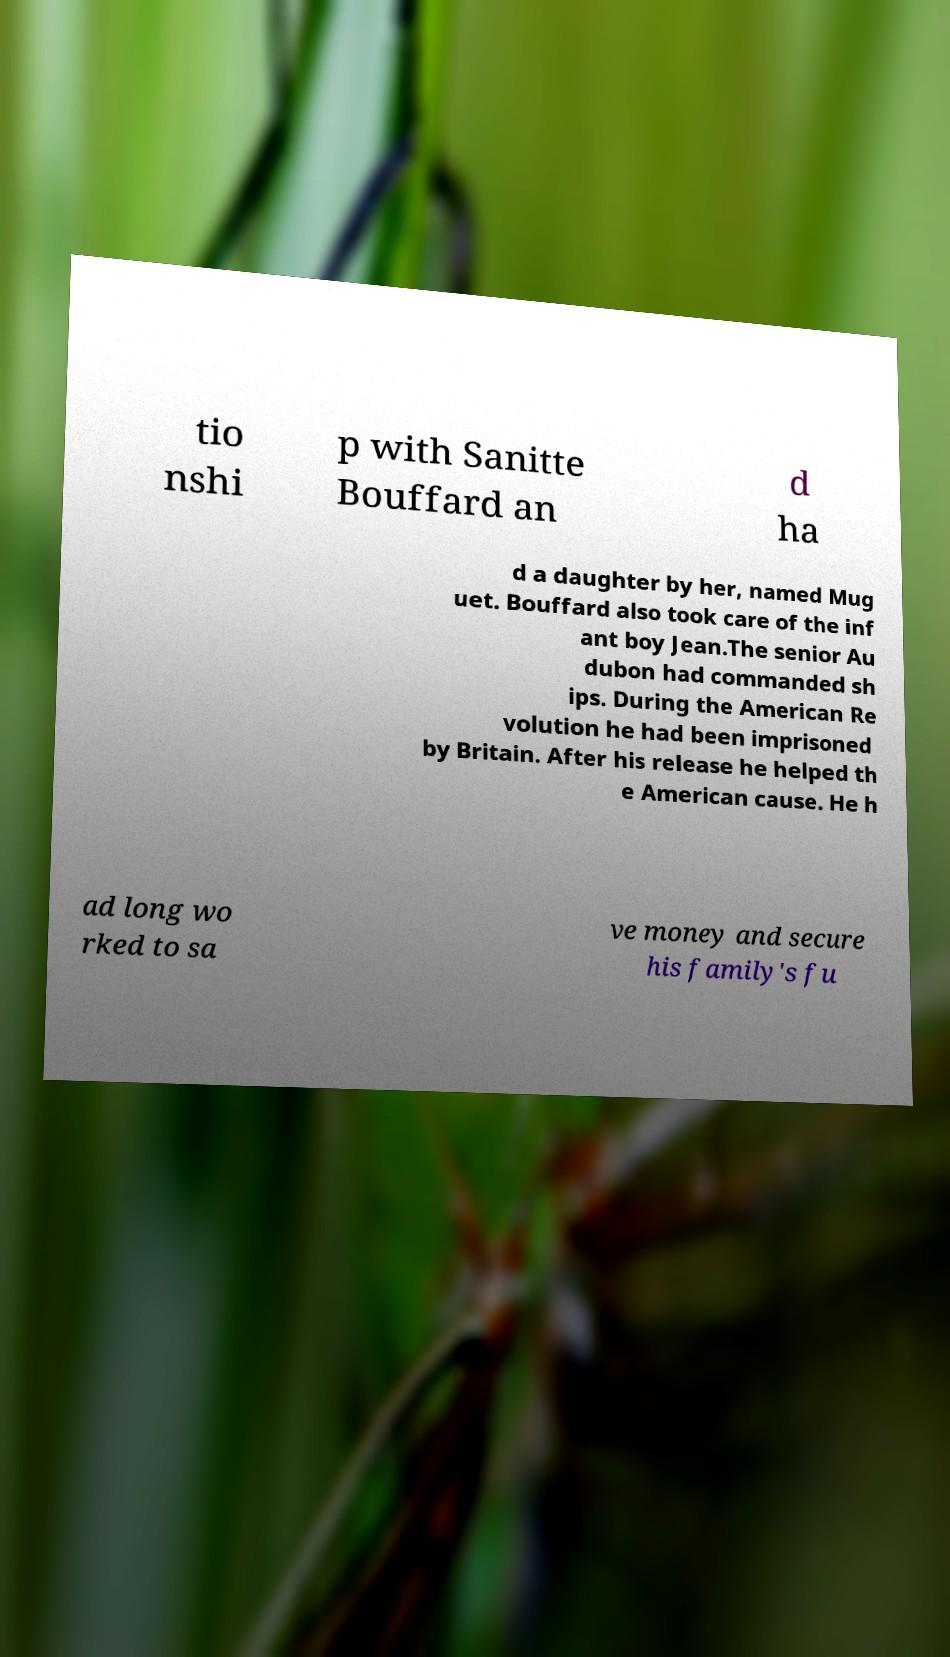For documentation purposes, I need the text within this image transcribed. Could you provide that? tio nshi p with Sanitte Bouffard an d ha d a daughter by her, named Mug uet. Bouffard also took care of the inf ant boy Jean.The senior Au dubon had commanded sh ips. During the American Re volution he had been imprisoned by Britain. After his release he helped th e American cause. He h ad long wo rked to sa ve money and secure his family's fu 